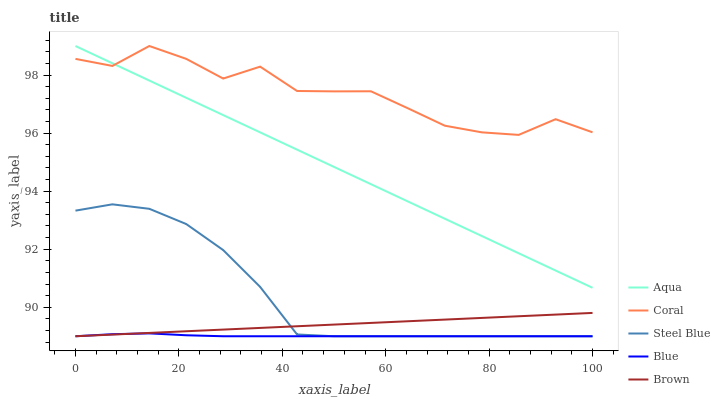Does Blue have the minimum area under the curve?
Answer yes or no. Yes. Does Coral have the maximum area under the curve?
Answer yes or no. Yes. Does Brown have the minimum area under the curve?
Answer yes or no. No. Does Brown have the maximum area under the curve?
Answer yes or no. No. Is Brown the smoothest?
Answer yes or no. Yes. Is Coral the roughest?
Answer yes or no. Yes. Is Coral the smoothest?
Answer yes or no. No. Is Brown the roughest?
Answer yes or no. No. Does Blue have the lowest value?
Answer yes or no. Yes. Does Coral have the lowest value?
Answer yes or no. No. Does Aqua have the highest value?
Answer yes or no. Yes. Does Brown have the highest value?
Answer yes or no. No. Is Blue less than Coral?
Answer yes or no. Yes. Is Coral greater than Brown?
Answer yes or no. Yes. Does Coral intersect Aqua?
Answer yes or no. Yes. Is Coral less than Aqua?
Answer yes or no. No. Is Coral greater than Aqua?
Answer yes or no. No. Does Blue intersect Coral?
Answer yes or no. No. 